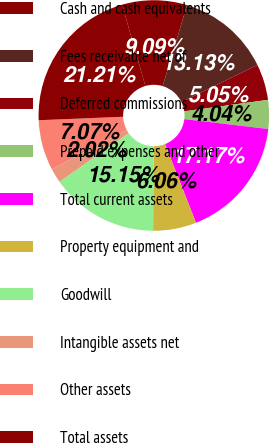Convert chart to OTSL. <chart><loc_0><loc_0><loc_500><loc_500><pie_chart><fcel>Cash and cash equivalents<fcel>Fees receivable net of<fcel>Deferred commissions<fcel>Prepaid expenses and other<fcel>Total current assets<fcel>Property equipment and<fcel>Goodwill<fcel>Intangible assets net<fcel>Other assets<fcel>Total assets<nl><fcel>9.09%<fcel>13.13%<fcel>5.05%<fcel>4.04%<fcel>17.17%<fcel>6.06%<fcel>15.15%<fcel>2.02%<fcel>7.07%<fcel>21.21%<nl></chart> 